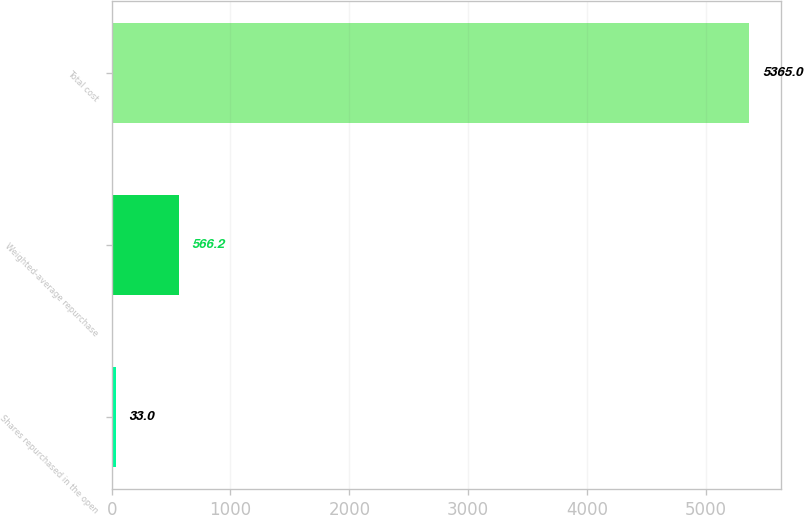<chart> <loc_0><loc_0><loc_500><loc_500><bar_chart><fcel>Shares repurchased in the open<fcel>Weighted-average repurchase<fcel>Total cost<nl><fcel>33<fcel>566.2<fcel>5365<nl></chart> 